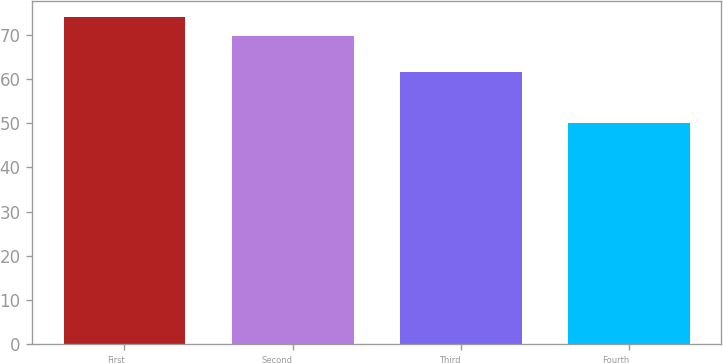<chart> <loc_0><loc_0><loc_500><loc_500><bar_chart><fcel>First<fcel>Second<fcel>Third<fcel>Fourth<nl><fcel>73.86<fcel>69.72<fcel>61.49<fcel>49.92<nl></chart> 